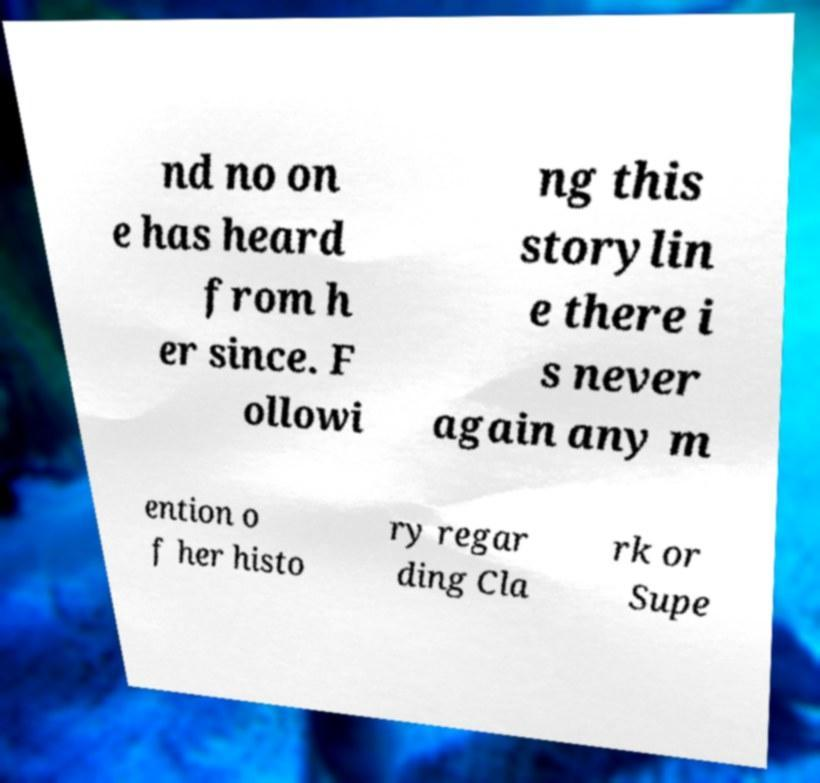Please read and relay the text visible in this image. What does it say? nd no on e has heard from h er since. F ollowi ng this storylin e there i s never again any m ention o f her histo ry regar ding Cla rk or Supe 